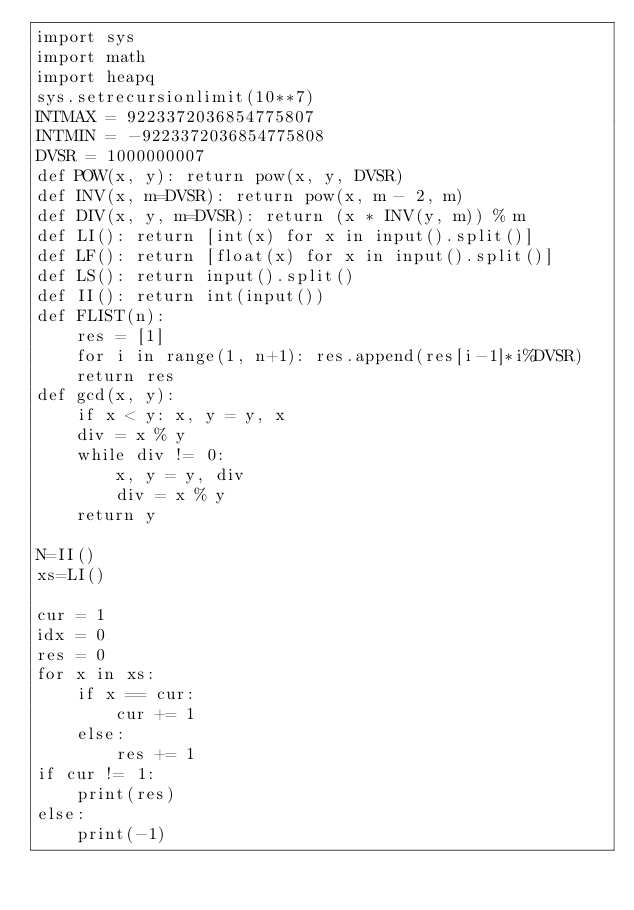<code> <loc_0><loc_0><loc_500><loc_500><_Python_>import sys
import math
import heapq
sys.setrecursionlimit(10**7)
INTMAX = 9223372036854775807
INTMIN = -9223372036854775808
DVSR = 1000000007
def POW(x, y): return pow(x, y, DVSR)
def INV(x, m=DVSR): return pow(x, m - 2, m)
def DIV(x, y, m=DVSR): return (x * INV(y, m)) % m
def LI(): return [int(x) for x in input().split()]
def LF(): return [float(x) for x in input().split()]
def LS(): return input().split()
def II(): return int(input())
def FLIST(n):
    res = [1]
    for i in range(1, n+1): res.append(res[i-1]*i%DVSR)
    return res
def gcd(x, y):
    if x < y: x, y = y, x
    div = x % y
    while div != 0:
        x, y = y, div
        div = x % y
    return y
 
N=II()
xs=LI()
 
cur = 1
idx = 0
res = 0
for x in xs:
    if x == cur:
        cur += 1
    else:
        res += 1
if cur != 1:
    print(res)
else:
    print(-1)</code> 